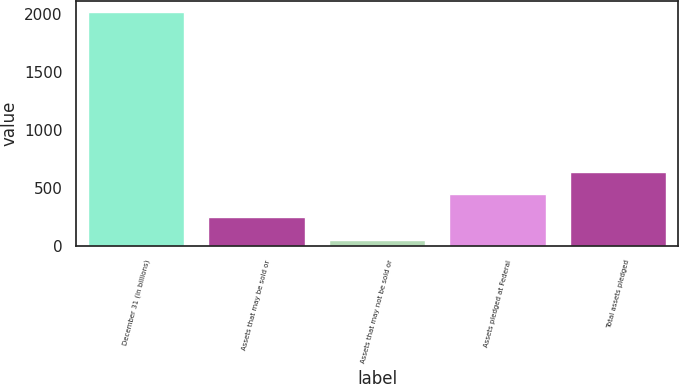Convert chart. <chart><loc_0><loc_0><loc_500><loc_500><bar_chart><fcel>December 31 (in billions)<fcel>Assets that may be sold or<fcel>Assets that may not be sold or<fcel>Assets pledged at Federal<fcel>Total assets pledged<nl><fcel>2016<fcel>249.75<fcel>53.5<fcel>446<fcel>642.25<nl></chart> 